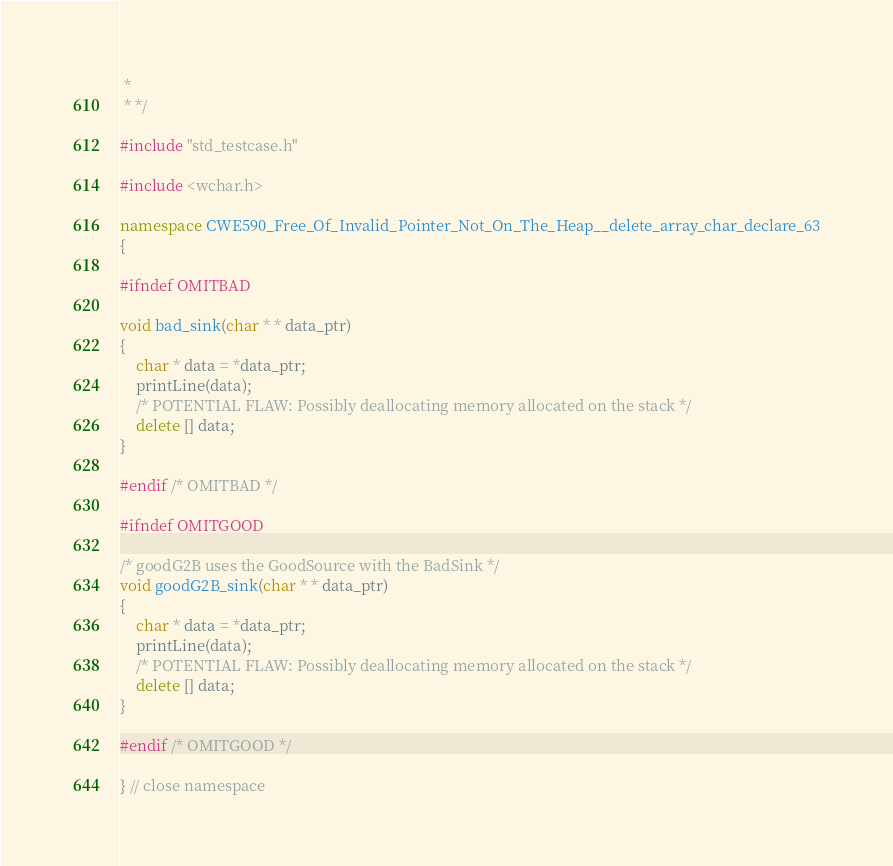Convert code to text. <code><loc_0><loc_0><loc_500><loc_500><_C++_> *
 * */

#include "std_testcase.h"

#include <wchar.h>

namespace CWE590_Free_Of_Invalid_Pointer_Not_On_The_Heap__delete_array_char_declare_63
{

#ifndef OMITBAD

void bad_sink(char * * data_ptr)
{
    char * data = *data_ptr;
    printLine(data);
    /* POTENTIAL FLAW: Possibly deallocating memory allocated on the stack */
    delete [] data;
}

#endif /* OMITBAD */

#ifndef OMITGOOD

/* goodG2B uses the GoodSource with the BadSink */
void goodG2B_sink(char * * data_ptr)
{
    char * data = *data_ptr;
    printLine(data);
    /* POTENTIAL FLAW: Possibly deallocating memory allocated on the stack */
    delete [] data;
}

#endif /* OMITGOOD */

} // close namespace
</code> 